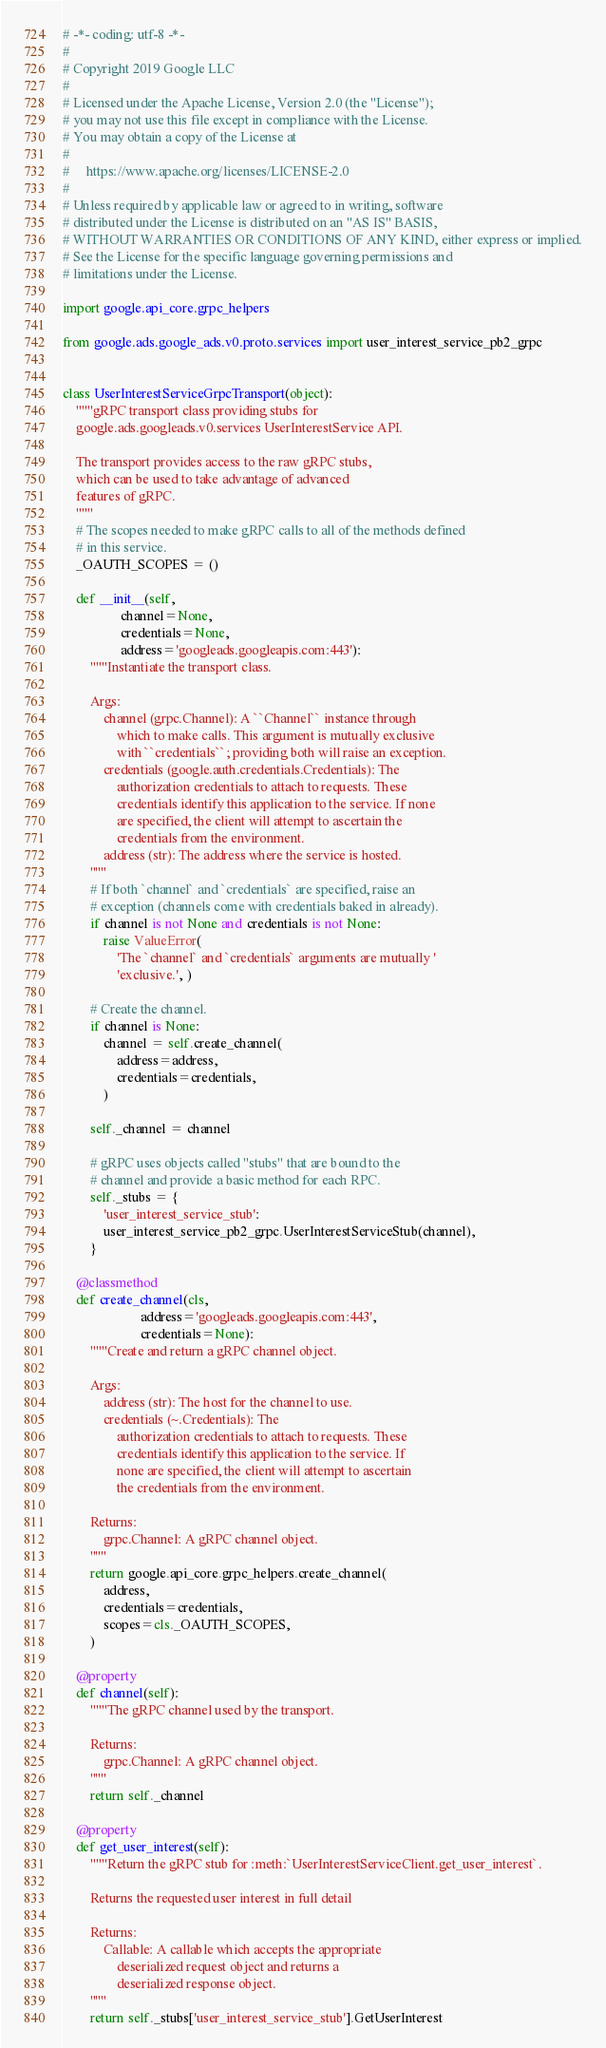<code> <loc_0><loc_0><loc_500><loc_500><_Python_># -*- coding: utf-8 -*-
#
# Copyright 2019 Google LLC
#
# Licensed under the Apache License, Version 2.0 (the "License");
# you may not use this file except in compliance with the License.
# You may obtain a copy of the License at
#
#     https://www.apache.org/licenses/LICENSE-2.0
#
# Unless required by applicable law or agreed to in writing, software
# distributed under the License is distributed on an "AS IS" BASIS,
# WITHOUT WARRANTIES OR CONDITIONS OF ANY KIND, either express or implied.
# See the License for the specific language governing permissions and
# limitations under the License.

import google.api_core.grpc_helpers

from google.ads.google_ads.v0.proto.services import user_interest_service_pb2_grpc


class UserInterestServiceGrpcTransport(object):
    """gRPC transport class providing stubs for
    google.ads.googleads.v0.services UserInterestService API.

    The transport provides access to the raw gRPC stubs,
    which can be used to take advantage of advanced
    features of gRPC.
    """
    # The scopes needed to make gRPC calls to all of the methods defined
    # in this service.
    _OAUTH_SCOPES = ()

    def __init__(self,
                 channel=None,
                 credentials=None,
                 address='googleads.googleapis.com:443'):
        """Instantiate the transport class.

        Args:
            channel (grpc.Channel): A ``Channel`` instance through
                which to make calls. This argument is mutually exclusive
                with ``credentials``; providing both will raise an exception.
            credentials (google.auth.credentials.Credentials): The
                authorization credentials to attach to requests. These
                credentials identify this application to the service. If none
                are specified, the client will attempt to ascertain the
                credentials from the environment.
            address (str): The address where the service is hosted.
        """
        # If both `channel` and `credentials` are specified, raise an
        # exception (channels come with credentials baked in already).
        if channel is not None and credentials is not None:
            raise ValueError(
                'The `channel` and `credentials` arguments are mutually '
                'exclusive.', )

        # Create the channel.
        if channel is None:
            channel = self.create_channel(
                address=address,
                credentials=credentials,
            )

        self._channel = channel

        # gRPC uses objects called "stubs" that are bound to the
        # channel and provide a basic method for each RPC.
        self._stubs = {
            'user_interest_service_stub':
            user_interest_service_pb2_grpc.UserInterestServiceStub(channel),
        }

    @classmethod
    def create_channel(cls,
                       address='googleads.googleapis.com:443',
                       credentials=None):
        """Create and return a gRPC channel object.

        Args:
            address (str): The host for the channel to use.
            credentials (~.Credentials): The
                authorization credentials to attach to requests. These
                credentials identify this application to the service. If
                none are specified, the client will attempt to ascertain
                the credentials from the environment.

        Returns:
            grpc.Channel: A gRPC channel object.
        """
        return google.api_core.grpc_helpers.create_channel(
            address,
            credentials=credentials,
            scopes=cls._OAUTH_SCOPES,
        )

    @property
    def channel(self):
        """The gRPC channel used by the transport.

        Returns:
            grpc.Channel: A gRPC channel object.
        """
        return self._channel

    @property
    def get_user_interest(self):
        """Return the gRPC stub for :meth:`UserInterestServiceClient.get_user_interest`.

        Returns the requested user interest in full detail

        Returns:
            Callable: A callable which accepts the appropriate
                deserialized request object and returns a
                deserialized response object.
        """
        return self._stubs['user_interest_service_stub'].GetUserInterest
</code> 